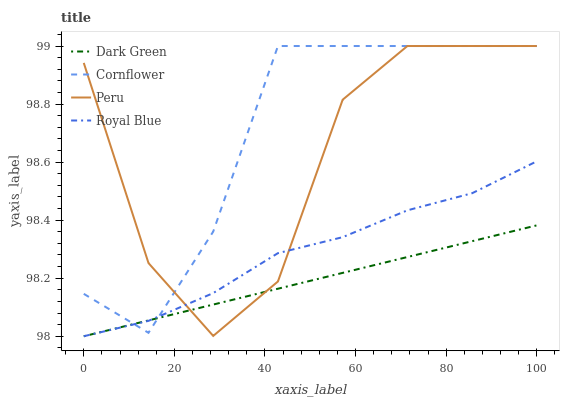Does Dark Green have the minimum area under the curve?
Answer yes or no. Yes. Does Cornflower have the maximum area under the curve?
Answer yes or no. Yes. Does Peru have the minimum area under the curve?
Answer yes or no. No. Does Peru have the maximum area under the curve?
Answer yes or no. No. Is Dark Green the smoothest?
Answer yes or no. Yes. Is Peru the roughest?
Answer yes or no. Yes. Is Cornflower the smoothest?
Answer yes or no. No. Is Cornflower the roughest?
Answer yes or no. No. Does Royal Blue have the lowest value?
Answer yes or no. Yes. Does Peru have the lowest value?
Answer yes or no. No. Does Peru have the highest value?
Answer yes or no. Yes. Does Dark Green have the highest value?
Answer yes or no. No. Does Dark Green intersect Royal Blue?
Answer yes or no. Yes. Is Dark Green less than Royal Blue?
Answer yes or no. No. Is Dark Green greater than Royal Blue?
Answer yes or no. No. 